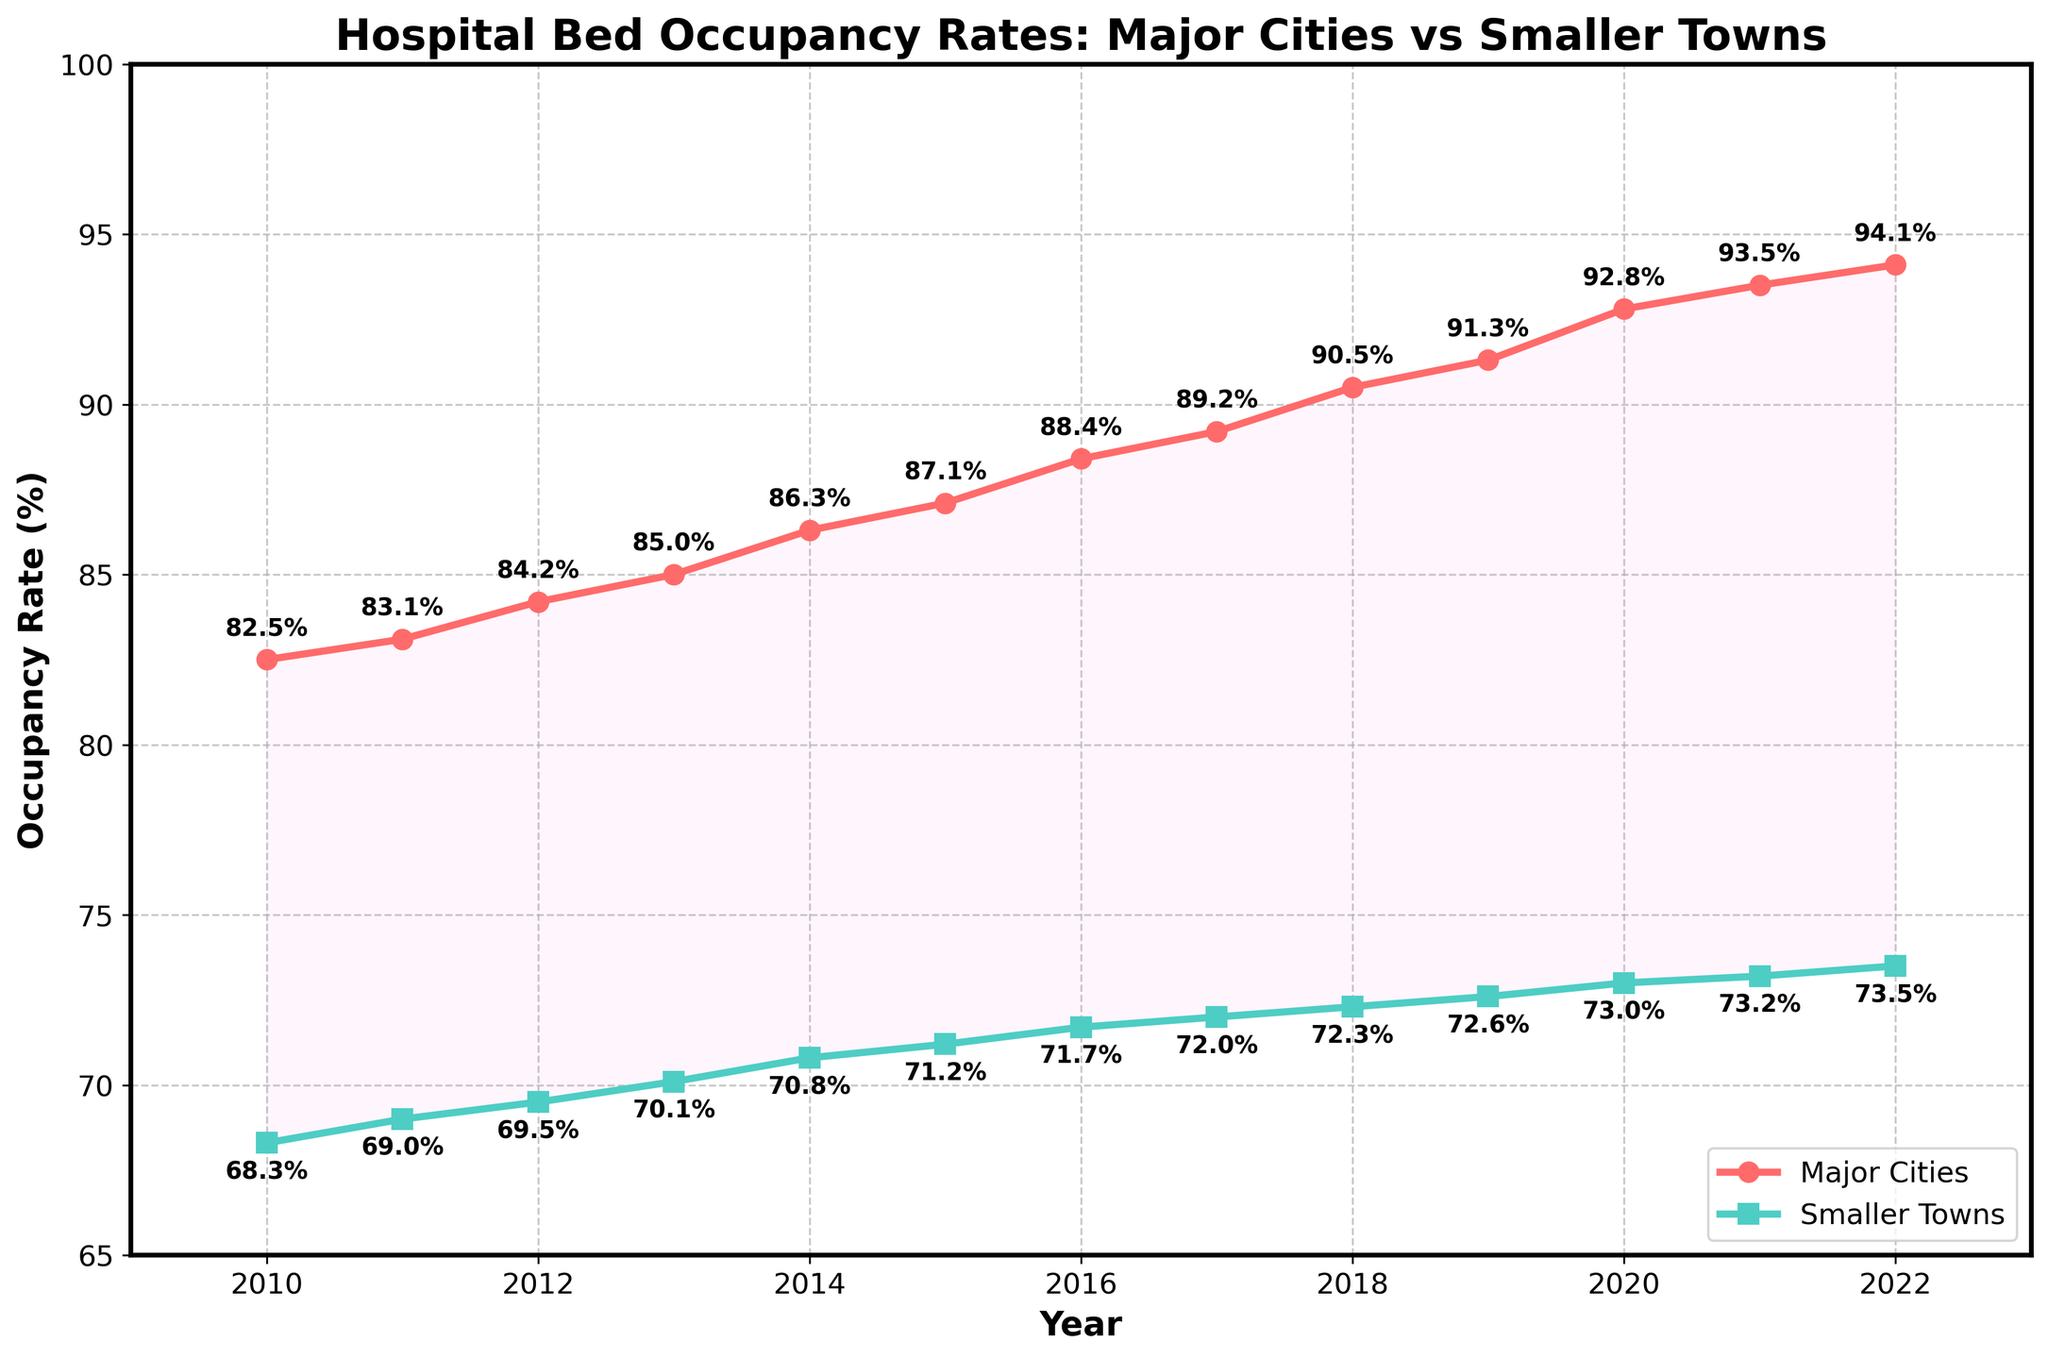what trend can we observe for hospital bed occupancy rates in major cities from 2010 to 2022? The line representing major cities shows a consistent upward trend from 82.5% in 2010 to 94.1% in 2022.
Answer: Upward trend Which year shows the highest occupancy rate for smaller towns? By examining the chart, the highest occupancy rate for smaller towns is in 2022, which is 73.5%.
Answer: 2022 How does the occupancy rate in major cities in 2015 compare to smaller towns in the same year? For 2015, the occupancy rate in major cities is 87.1%, whereas for smaller towns it is 71.2%. The occupancy rate in major cities is significantly higher than in smaller towns.
Answer: Major cities have a higher rate By how much did the occupancy rate in major cities increase from 2010 to 2022? Subtract the occupancy rate of 2010 (82.5%) from the occupancy rate of 2022 (94.1%). The increase is 94.1% - 82.5% = 11.6%.
Answer: 11.6% What is the difference in occupancy rates between major cities and smaller towns in 2022? The occupancy rate for major cities in 2022 is 94.1%, and for smaller towns, it is 73.5%. The difference is 94.1% - 73.5% = 20.6%.
Answer: 20.6% During which year is the gap between major cities and smaller towns smallest? The smallest gap can be observed visually by comparing the two lines. In 2010, the gap appears smallest with major cities at 82.5% and smaller towns at 68.3%, giving a difference of 82.5% - 68.3% = 14.2%.
Answer: 2010 What trend can be seen in the difference between the occupancy rates of major cities and smaller towns over the years? The difference between the occupancy rates generally increases over the years. For instance, in 2010, the gap is 14.2%, and by 2022, it has increased to 20.6%.
Answer: Increasing trend Which year shows a rapid increase in the occupancy rate for major cities when compared to the previous year? By examining the year-over-year changes, the sharpest increase occurs between 2017 and 2018, where it goes from 89.2% to 90.5%.
Answer: 2018 By what percentage did the occupancy rate in smaller towns increase from 2010 to 2022? The occupancy rate in smaller towns in 2010 is 68.3%, and by 2022 it is 73.5%. The percentage increase is [(73.5 - 68.3) / 68.3] * 100 ≈ 7.6%.
Answer: 7.6% What is the average occupancy rate for major cities from 2010 to 2022? Sum the occupancy rates for major cities from 2010 to 2022 and divide by the number of years: (82.5 + 83.1 + 84.2 + 85.0 + 86.3 + 87.1 + 88.4 + 89.2 + 90.5 + 91.3 + 92.8 + 93.5 + 94.1) / 13 ≈ 88.6%.
Answer: 88.6% 